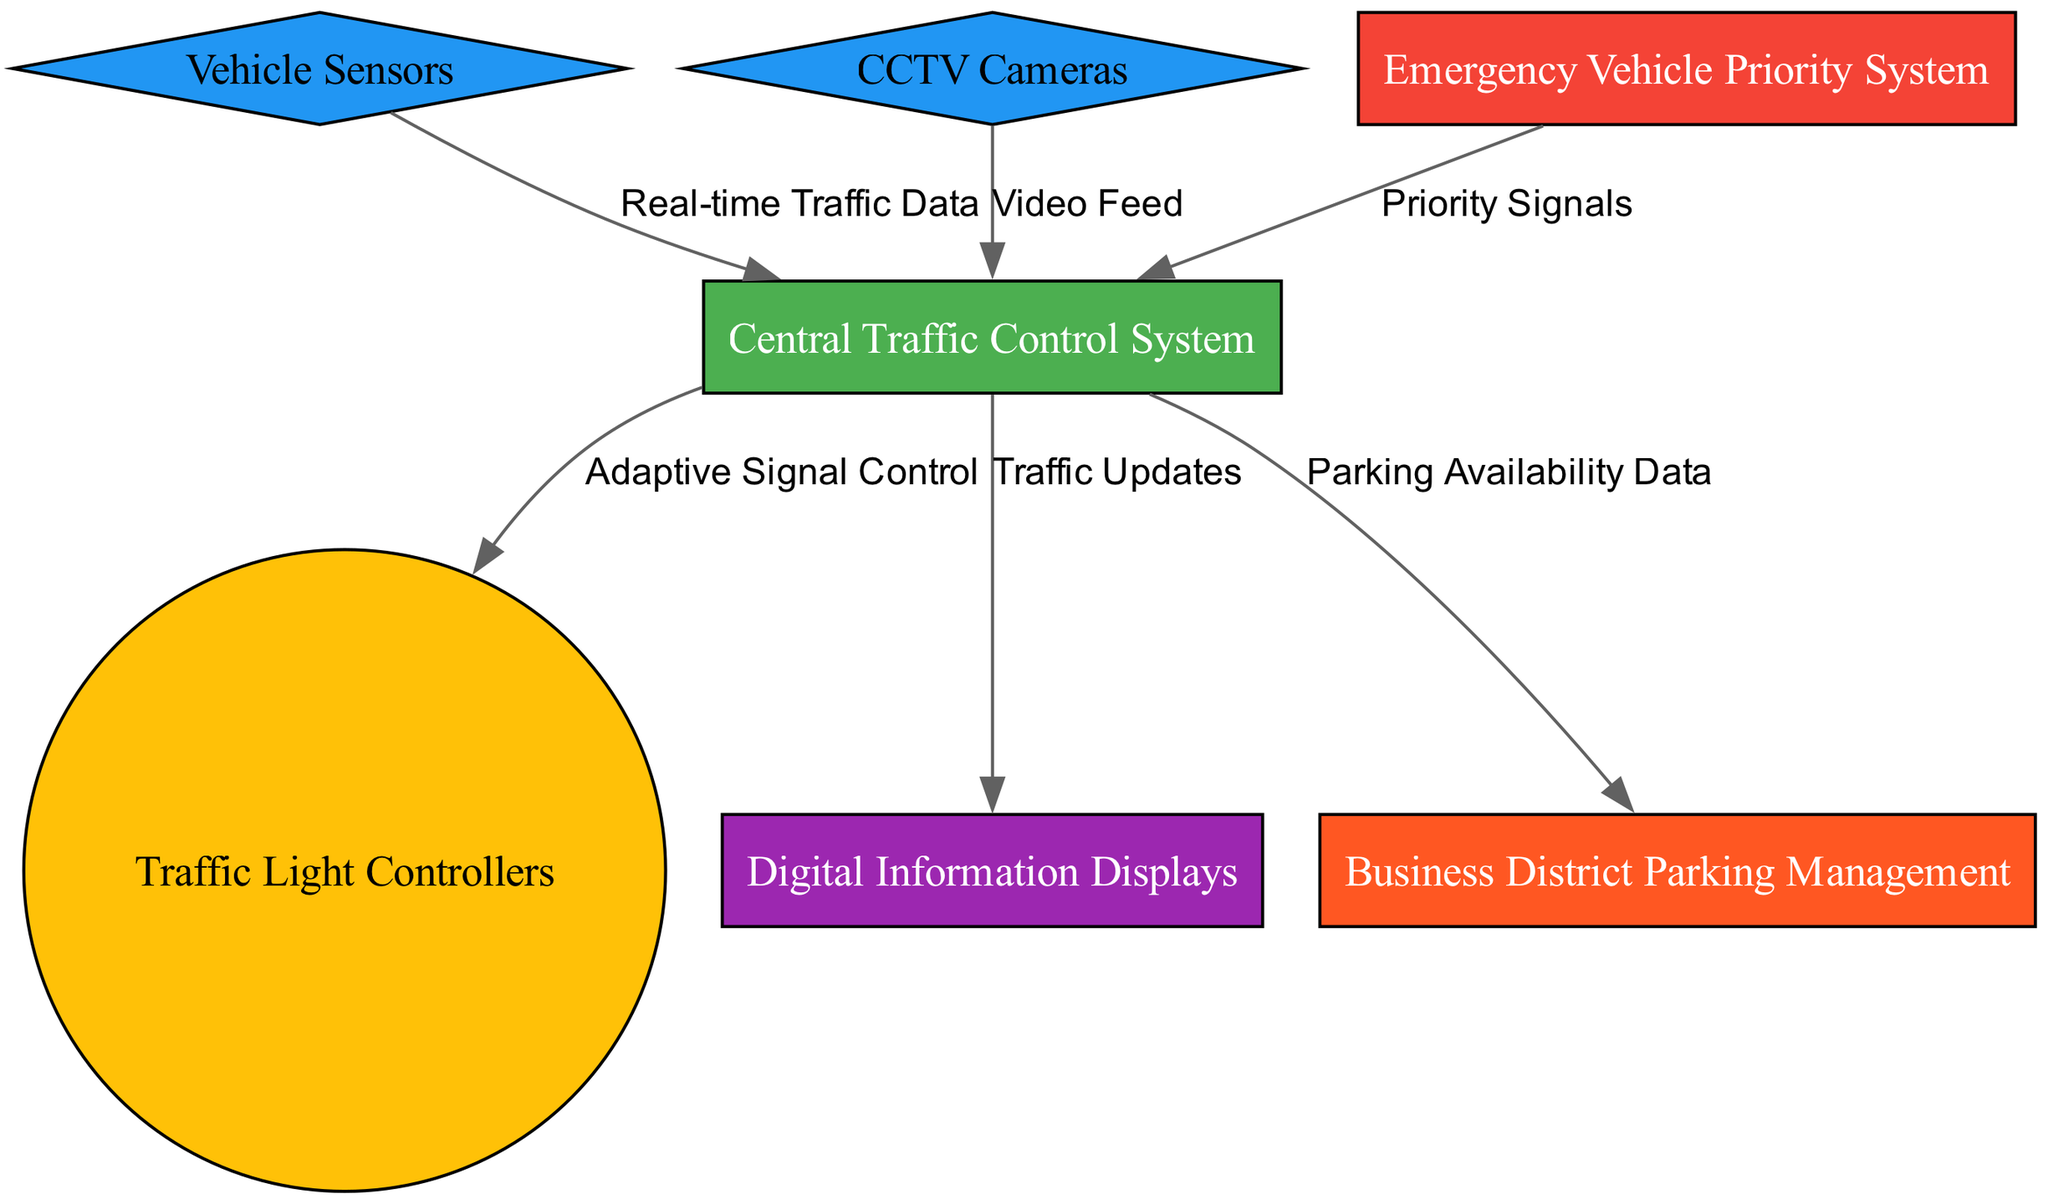What is the total number of nodes in the diagram? The diagram lists several entities that make up the smart traffic management system. By counting each unique entity represented as a node, we find that there are 7 nodes in total.
Answer: 7 Which node is responsible for providing real-time traffic data? The Vehicle Sensors node provides real-time traffic data to the Central Traffic Control System, as indicated by the connection in the diagram.
Answer: Vehicle Sensors What type of system is indicated by the node labeled "Emergency Vehicle Priority System"? The Emergency Vehicle Priority System is represented as a rectangle in the diagram, which is a common shape for functional systems or management components in engineering diagrams. This node handles priority signals for emergency vehicles.
Answer: Emergency Vehicle Priority System How many edges are connecting the Central Traffic Control System to other nodes? The Central Traffic Control System has 5 outgoing connections (edges) leading to other nodes, as shown in the diagram, indicating its central role in managing communication between various components.
Answer: 5 What is the relationship between the CCTV Cameras and the Central Traffic Control System? The CCTV Cameras send a video feed to the Central Traffic Control System, as represented by the directed edge between these two nodes in the diagram.
Answer: Video Feed What information is provided to the Digital Information Displays node? The Digital Information Displays receive traffic updates from the Central Traffic Control System, which is illustrated by the directed edge in the diagram.
Answer: Traffic Updates Which node connects to the Business District Parking Management node and what kind of data does it provide? The Central Traffic Control System connects to the Business District Parking Management node, providing parking availability data, as clearly stated in the directed edge between these nodes in the diagram.
Answer: Parking Availability Data What unique feature is represented by the shape of the Vehicle Sensors node? The Vehicle Sensors node is shaped as a diamond, which often symbolizes decision points or critical monitoring functions in engineering diagrams. This shape indicates its role in sensing and providing data input to the Central Traffic Control System.
Answer: Diamond 